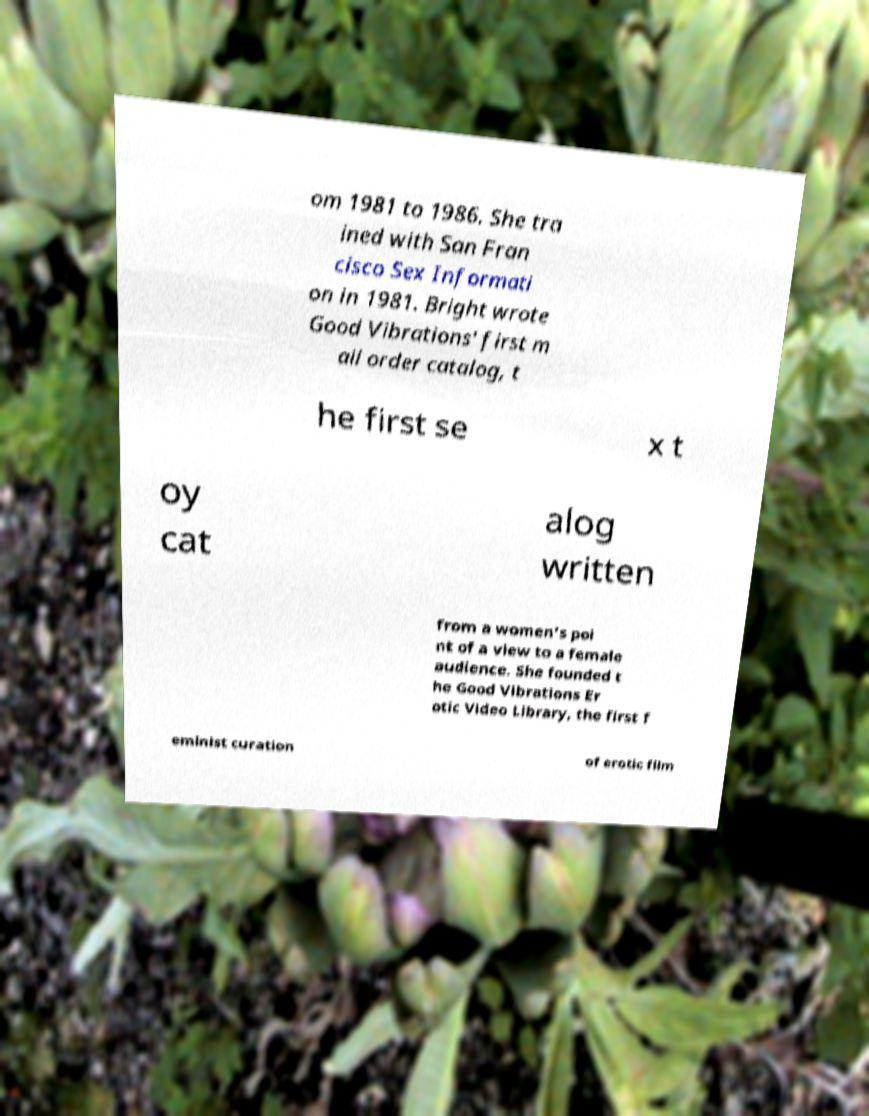There's text embedded in this image that I need extracted. Can you transcribe it verbatim? om 1981 to 1986. She tra ined with San Fran cisco Sex Informati on in 1981. Bright wrote Good Vibrations' first m ail order catalog, t he first se x t oy cat alog written from a women's poi nt of a view to a female audience. She founded t he Good Vibrations Er otic Video Library, the first f eminist curation of erotic film 